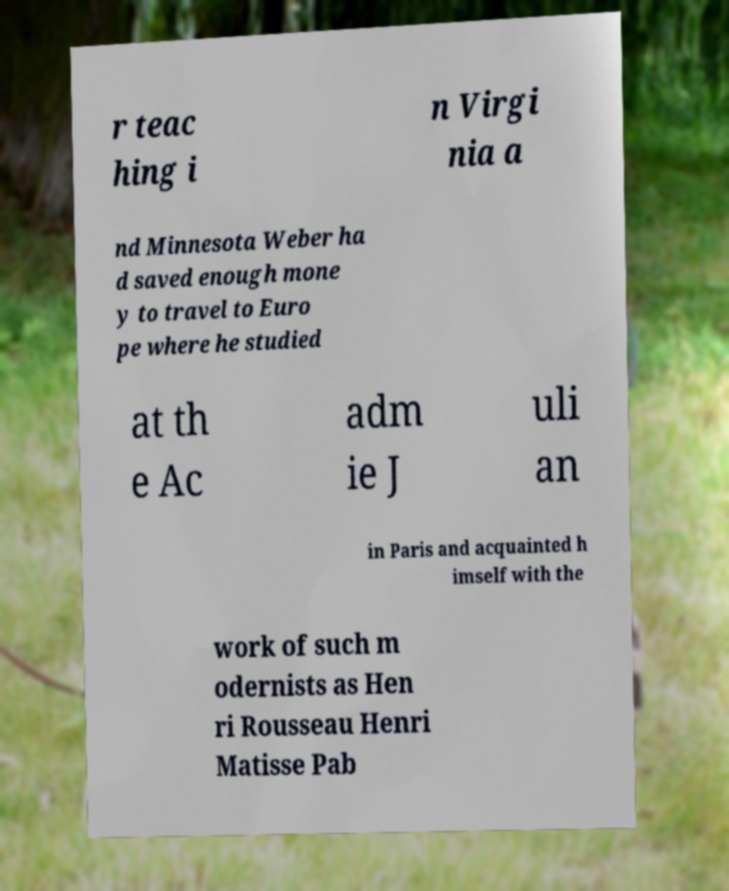There's text embedded in this image that I need extracted. Can you transcribe it verbatim? r teac hing i n Virgi nia a nd Minnesota Weber ha d saved enough mone y to travel to Euro pe where he studied at th e Ac adm ie J uli an in Paris and acquainted h imself with the work of such m odernists as Hen ri Rousseau Henri Matisse Pab 